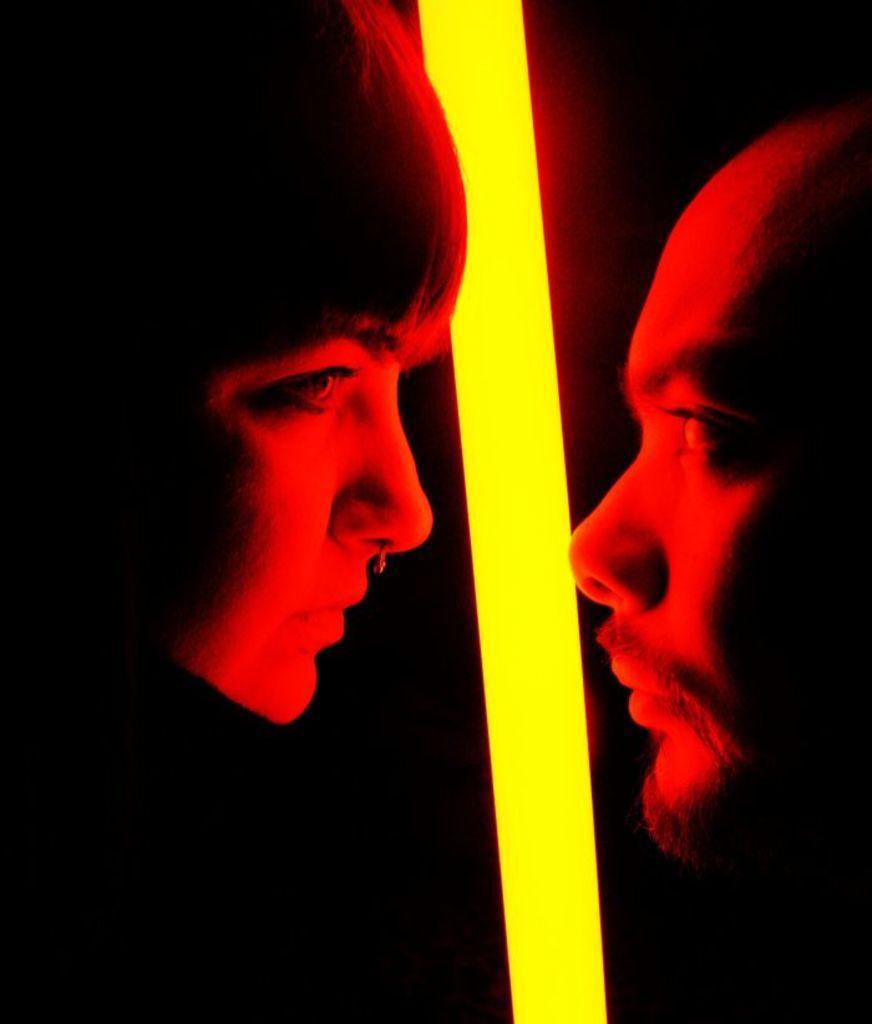Please provide a concise description of this image. Here in this picture we can see faces of a man and a woman present over there and in the middle we can see a light present over there. 